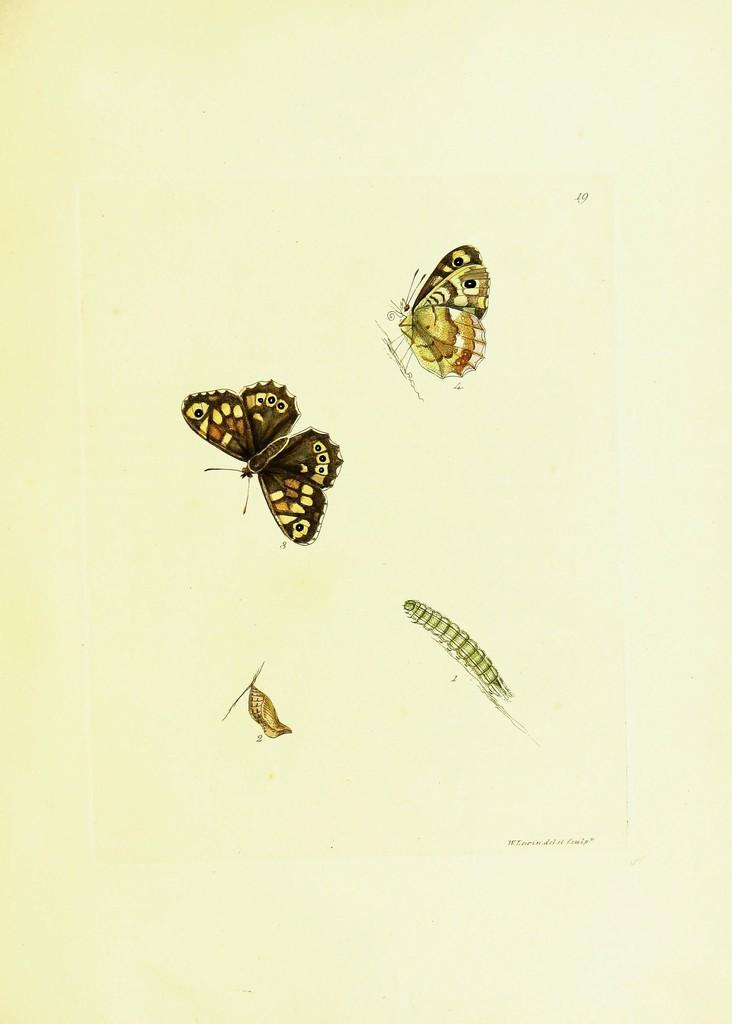What is depicted in the images in the picture? The images in the picture show the stages of a butterfly. What is the medium on which the images are displayed? The images are on a paper. What type of pie is being served on the table in the image? There is no table or pie present in the image; it only features pictures of the stages of a butterfly on a paper. What type of beam is holding up the roof in the image? There is no roof or beam present in the image; it only features pictures of the stages of a butterfly on a paper. 